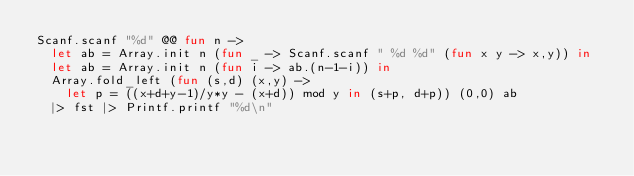<code> <loc_0><loc_0><loc_500><loc_500><_OCaml_>Scanf.scanf "%d" @@ fun n ->
  let ab = Array.init n (fun _ -> Scanf.scanf " %d %d" (fun x y -> x,y)) in
  let ab = Array.init n (fun i -> ab.(n-1-i)) in
  Array.fold_left (fun (s,d) (x,y) ->
    let p = ((x+d+y-1)/y*y - (x+d)) mod y in (s+p, d+p)) (0,0) ab
  |> fst |> Printf.printf "%d\n"</code> 